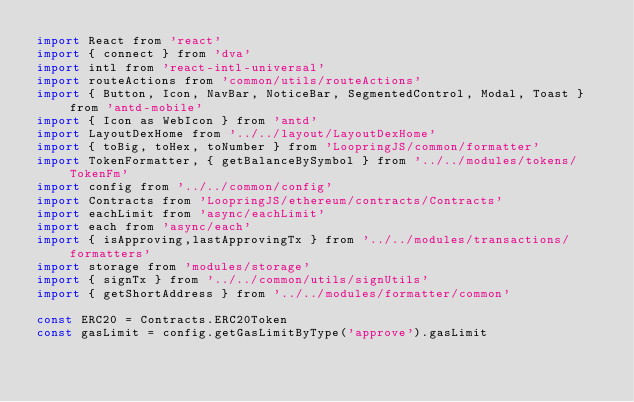<code> <loc_0><loc_0><loc_500><loc_500><_JavaScript_>import React from 'react'
import { connect } from 'dva'
import intl from 'react-intl-universal'
import routeActions from 'common/utils/routeActions'
import { Button, Icon, NavBar, NoticeBar, SegmentedControl, Modal, Toast } from 'antd-mobile'
import { Icon as WebIcon } from 'antd'
import LayoutDexHome from '../../layout/LayoutDexHome'
import { toBig, toHex, toNumber } from 'LoopringJS/common/formatter'
import TokenFormatter, { getBalanceBySymbol } from '../../modules/tokens/TokenFm'
import config from '../../common/config'
import Contracts from 'LoopringJS/ethereum/contracts/Contracts'
import eachLimit from 'async/eachLimit'
import each from 'async/each'
import { isApproving,lastApprovingTx } from '../../modules/transactions/formatters'
import storage from 'modules/storage'
import { signTx } from '../../common/utils/signUtils'
import { getShortAddress } from '../../modules/formatter/common'

const ERC20 = Contracts.ERC20Token
const gasLimit = config.getGasLimitByType('approve').gasLimit
</code> 